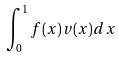Convert formula to latex. <formula><loc_0><loc_0><loc_500><loc_500>\int _ { 0 } ^ { 1 } f ( x ) v ( x ) d x</formula> 